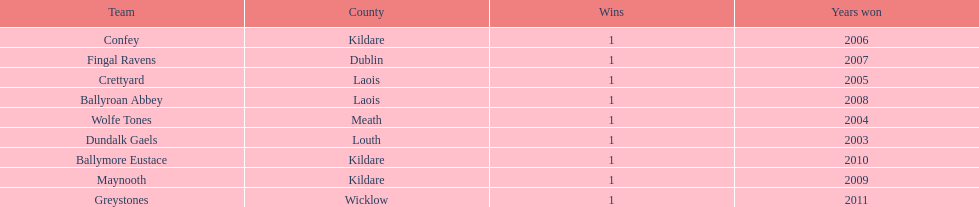Which team won previous to crettyard? Wolfe Tones. 